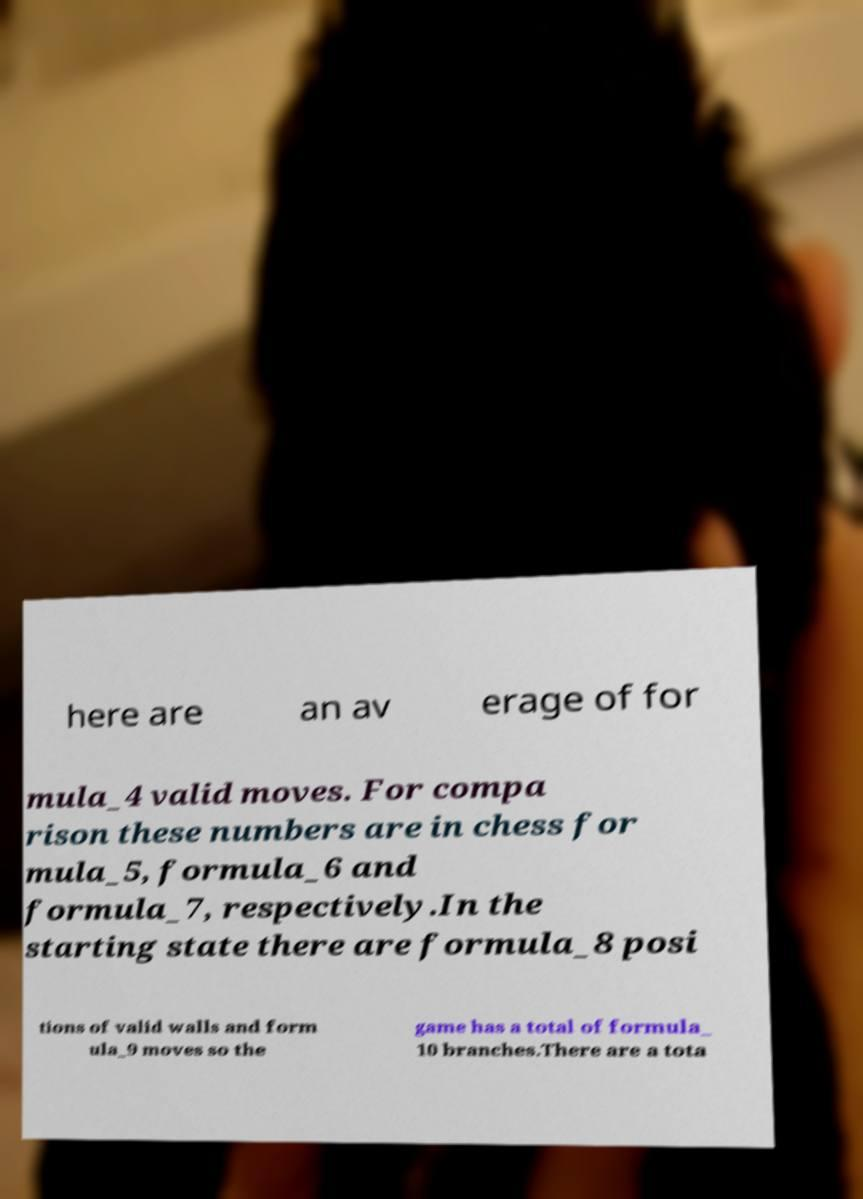Please identify and transcribe the text found in this image. here are an av erage of for mula_4 valid moves. For compa rison these numbers are in chess for mula_5, formula_6 and formula_7, respectively.In the starting state there are formula_8 posi tions of valid walls and form ula_9 moves so the game has a total of formula_ 10 branches.There are a tota 